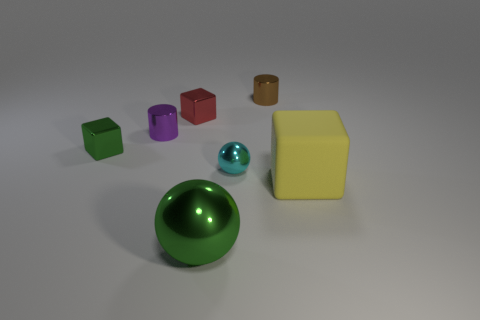How many other things are there of the same color as the large metal sphere?
Provide a short and direct response. 1. There is a green object that is to the left of the tiny red shiny cube; does it have the same size as the metal object behind the small red object?
Provide a succinct answer. Yes. Is the tiny green object made of the same material as the ball in front of the big yellow rubber cube?
Make the answer very short. Yes. Is the number of tiny metal cylinders in front of the big green thing greater than the number of rubber objects that are in front of the yellow matte thing?
Ensure brevity in your answer.  No. There is a small cylinder that is to the left of the metal ball that is in front of the large yellow object; what is its color?
Offer a terse response. Purple. What number of cylinders are small metallic objects or small cyan metallic objects?
Ensure brevity in your answer.  2. What number of things are to the left of the big metal ball and on the right side of the brown object?
Make the answer very short. 0. There is a metallic cylinder behind the purple shiny cylinder; what color is it?
Offer a terse response. Brown. There is a green sphere that is the same material as the tiny brown cylinder; what size is it?
Your answer should be very brief. Large. What number of green shiny objects are left of the green metallic object in front of the cyan sphere?
Provide a short and direct response. 1. 